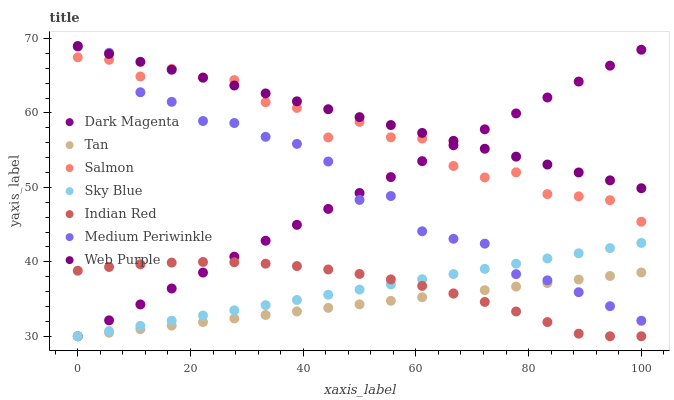Does Tan have the minimum area under the curve?
Answer yes or no. Yes. Does Web Purple have the maximum area under the curve?
Answer yes or no. Yes. Does Medium Periwinkle have the minimum area under the curve?
Answer yes or no. No. Does Medium Periwinkle have the maximum area under the curve?
Answer yes or no. No. Is Sky Blue the smoothest?
Answer yes or no. Yes. Is Salmon the roughest?
Answer yes or no. Yes. Is Medium Periwinkle the smoothest?
Answer yes or no. No. Is Medium Periwinkle the roughest?
Answer yes or no. No. Does Dark Magenta have the lowest value?
Answer yes or no. Yes. Does Medium Periwinkle have the lowest value?
Answer yes or no. No. Does Web Purple have the highest value?
Answer yes or no. Yes. Does Medium Periwinkle have the highest value?
Answer yes or no. No. Is Tan less than Salmon?
Answer yes or no. Yes. Is Web Purple greater than Tan?
Answer yes or no. Yes. Does Dark Magenta intersect Indian Red?
Answer yes or no. Yes. Is Dark Magenta less than Indian Red?
Answer yes or no. No. Is Dark Magenta greater than Indian Red?
Answer yes or no. No. Does Tan intersect Salmon?
Answer yes or no. No. 